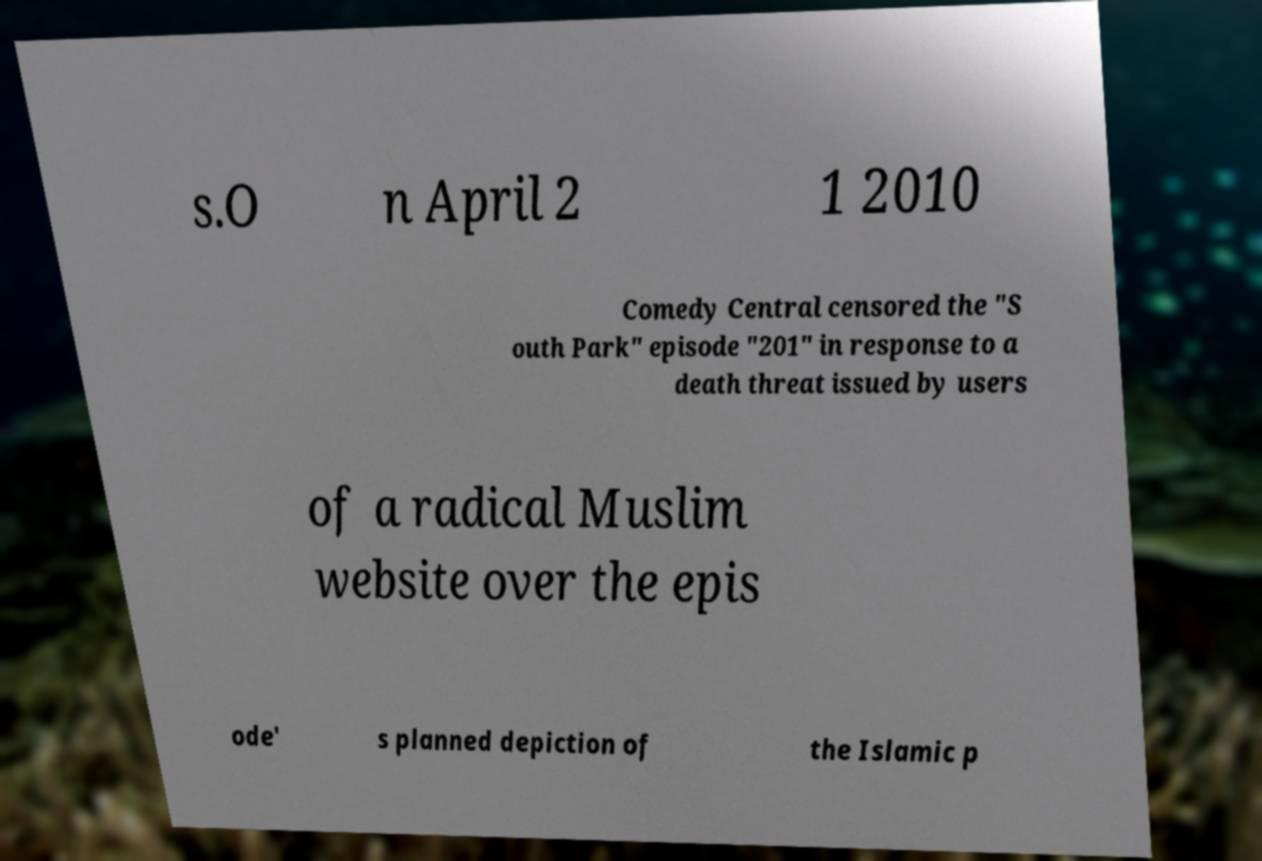What messages or text are displayed in this image? I need them in a readable, typed format. s.O n April 2 1 2010 Comedy Central censored the "S outh Park" episode "201" in response to a death threat issued by users of a radical Muslim website over the epis ode' s planned depiction of the Islamic p 